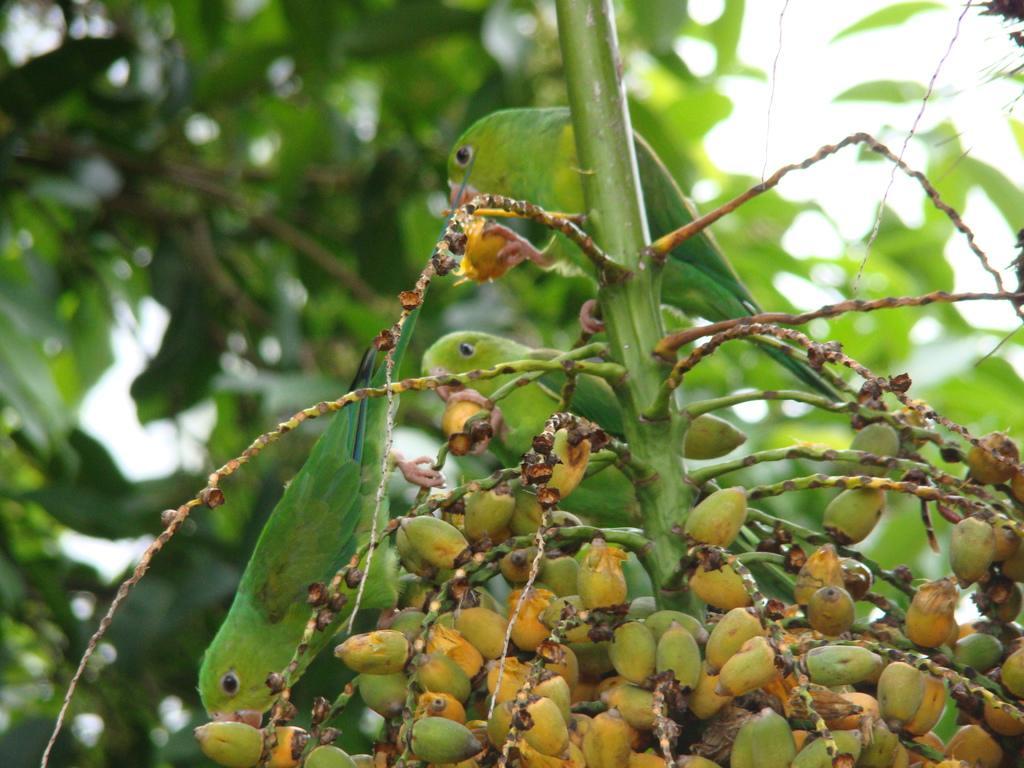Could you give a brief overview of what you see in this image? In the center of the image we can see the parrots on the stem. At the bottom of the image we can see the coconut palm. In the background of the image we can see the trees and sky. 